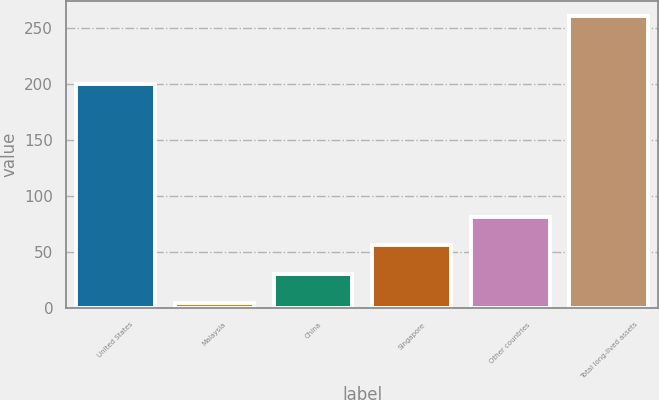<chart> <loc_0><loc_0><loc_500><loc_500><bar_chart><fcel>United States<fcel>Malaysia<fcel>China<fcel>Singapore<fcel>Other countries<fcel>Total long-lived assets<nl><fcel>200<fcel>5<fcel>30.6<fcel>56.2<fcel>81.8<fcel>261<nl></chart> 